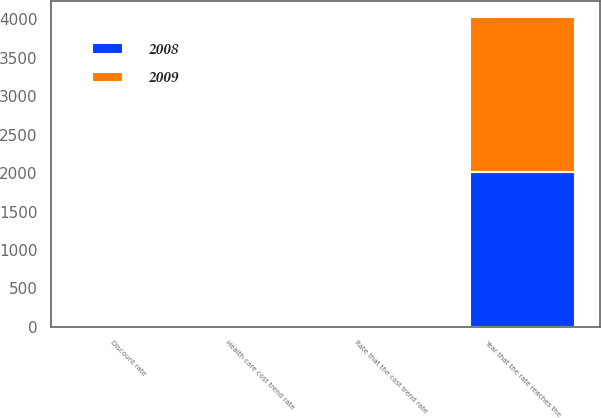Convert chart to OTSL. <chart><loc_0><loc_0><loc_500><loc_500><stacked_bar_chart><ecel><fcel>Discount rate<fcel>Health care cost trend rate<fcel>Rate that the cost trend rate<fcel>Year that the rate reaches the<nl><fcel>2008<fcel>5.4<fcel>9<fcel>5<fcel>2017<nl><fcel>2009<fcel>5.9<fcel>9.5<fcel>5<fcel>2017<nl></chart> 